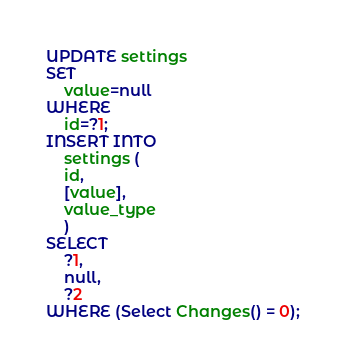Convert code to text. <code><loc_0><loc_0><loc_500><loc_500><_SQL_>UPDATE settings
SET 
    value=null
WHERE
    id=?1;
INSERT INTO 
    settings (
    id,
    [value],
    value_type
    )
SELECT   
    ?1,
    null,
    ?2
WHERE (Select Changes() = 0);
</code> 